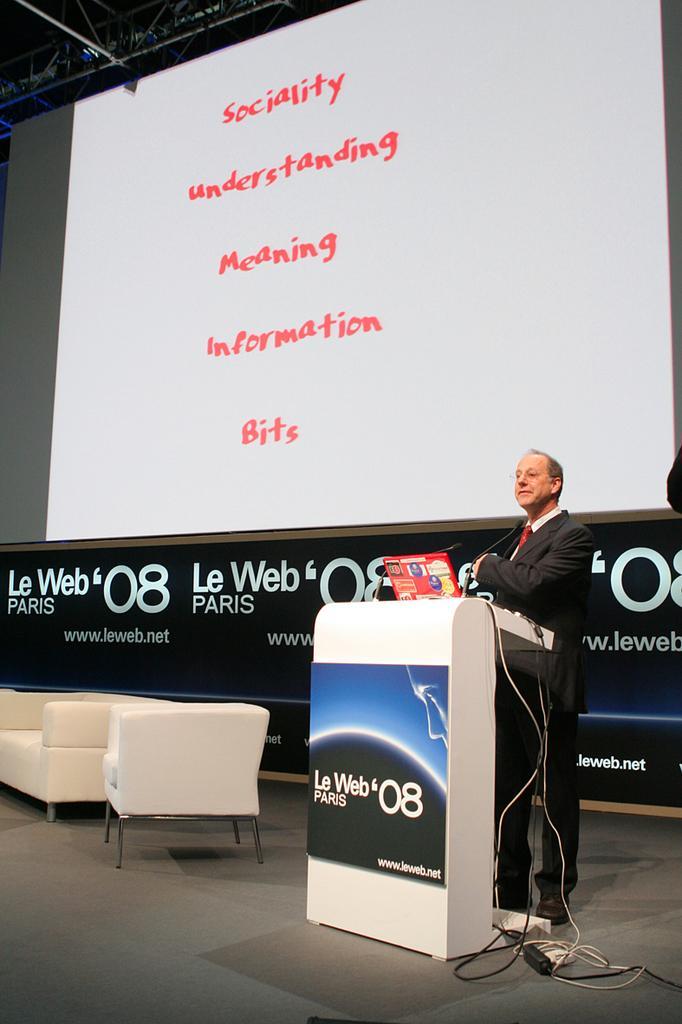Can you describe this image briefly? In this picture we can see a man standing in front of a podium and there is a board over a podium. These are chairs. On the background we can see hoarding and screen. This is a platform. 